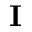Convert formula to latex. <formula><loc_0><loc_0><loc_500><loc_500>I</formula> 